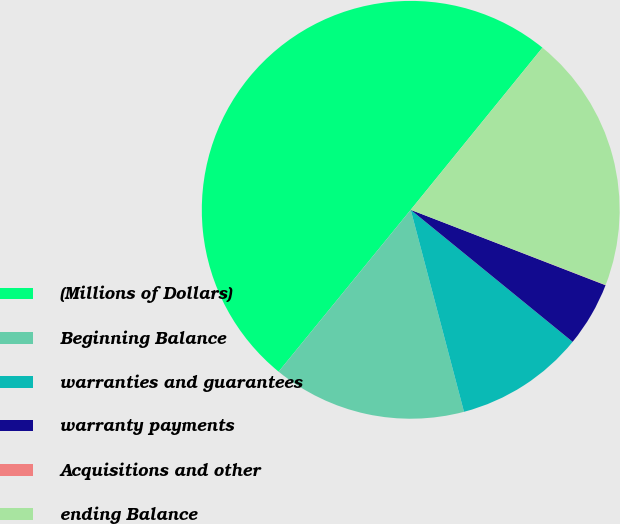<chart> <loc_0><loc_0><loc_500><loc_500><pie_chart><fcel>(Millions of Dollars)<fcel>Beginning Balance<fcel>warranties and guarantees<fcel>warranty payments<fcel>Acquisitions and other<fcel>ending Balance<nl><fcel>49.97%<fcel>15.0%<fcel>10.01%<fcel>5.01%<fcel>0.02%<fcel>20.0%<nl></chart> 